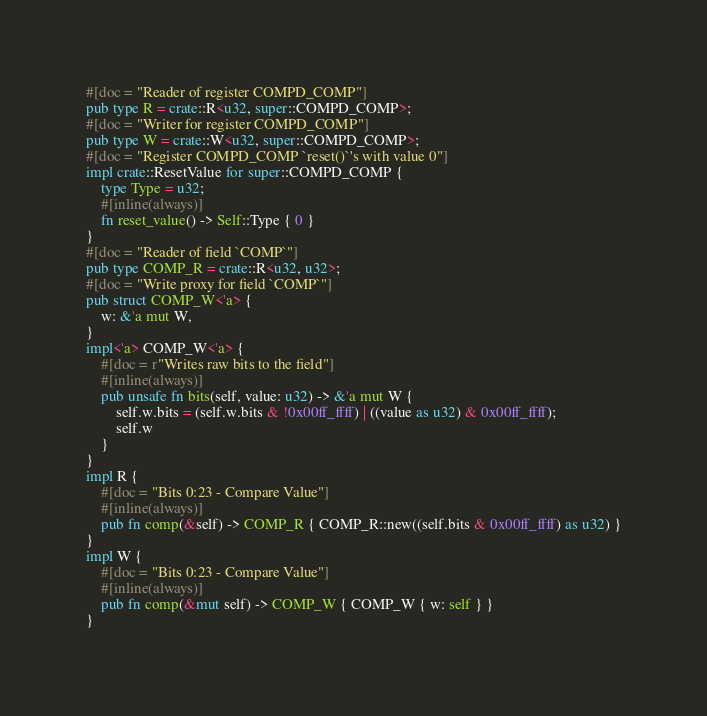Convert code to text. <code><loc_0><loc_0><loc_500><loc_500><_Rust_>#[doc = "Reader of register COMPD_COMP"]
pub type R = crate::R<u32, super::COMPD_COMP>;
#[doc = "Writer for register COMPD_COMP"]
pub type W = crate::W<u32, super::COMPD_COMP>;
#[doc = "Register COMPD_COMP `reset()`'s with value 0"]
impl crate::ResetValue for super::COMPD_COMP {
    type Type = u32;
    #[inline(always)]
    fn reset_value() -> Self::Type { 0 }
}
#[doc = "Reader of field `COMP`"]
pub type COMP_R = crate::R<u32, u32>;
#[doc = "Write proxy for field `COMP`"]
pub struct COMP_W<'a> {
    w: &'a mut W,
}
impl<'a> COMP_W<'a> {
    #[doc = r"Writes raw bits to the field"]
    #[inline(always)]
    pub unsafe fn bits(self, value: u32) -> &'a mut W {
        self.w.bits = (self.w.bits & !0x00ff_ffff) | ((value as u32) & 0x00ff_ffff);
        self.w
    }
}
impl R {
    #[doc = "Bits 0:23 - Compare Value"]
    #[inline(always)]
    pub fn comp(&self) -> COMP_R { COMP_R::new((self.bits & 0x00ff_ffff) as u32) }
}
impl W {
    #[doc = "Bits 0:23 - Compare Value"]
    #[inline(always)]
    pub fn comp(&mut self) -> COMP_W { COMP_W { w: self } }
}
</code> 